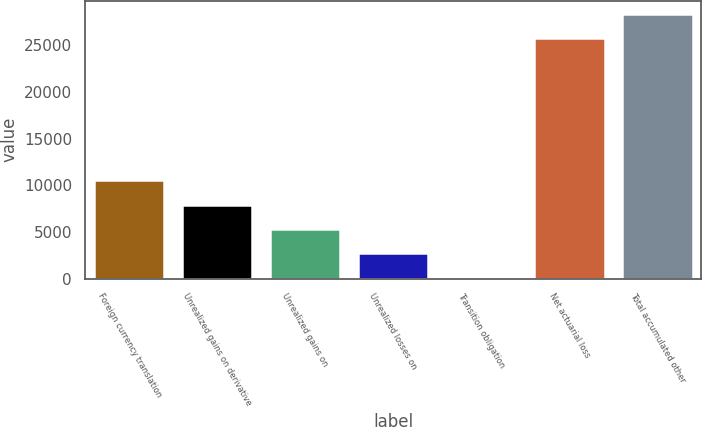Convert chart to OTSL. <chart><loc_0><loc_0><loc_500><loc_500><bar_chart><fcel>Foreign currency translation<fcel>Unrealized gains on derivative<fcel>Unrealized gains on<fcel>Unrealized losses on<fcel>Transition obligation<fcel>Net actuarial loss<fcel>Total accumulated other<nl><fcel>10537.8<fcel>7932.6<fcel>5327.4<fcel>2722.2<fcel>117<fcel>25755<fcel>28360.2<nl></chart> 